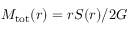<formula> <loc_0><loc_0><loc_500><loc_500>M _ { t o t } ( r ) = r S ( r ) / 2 G</formula> 